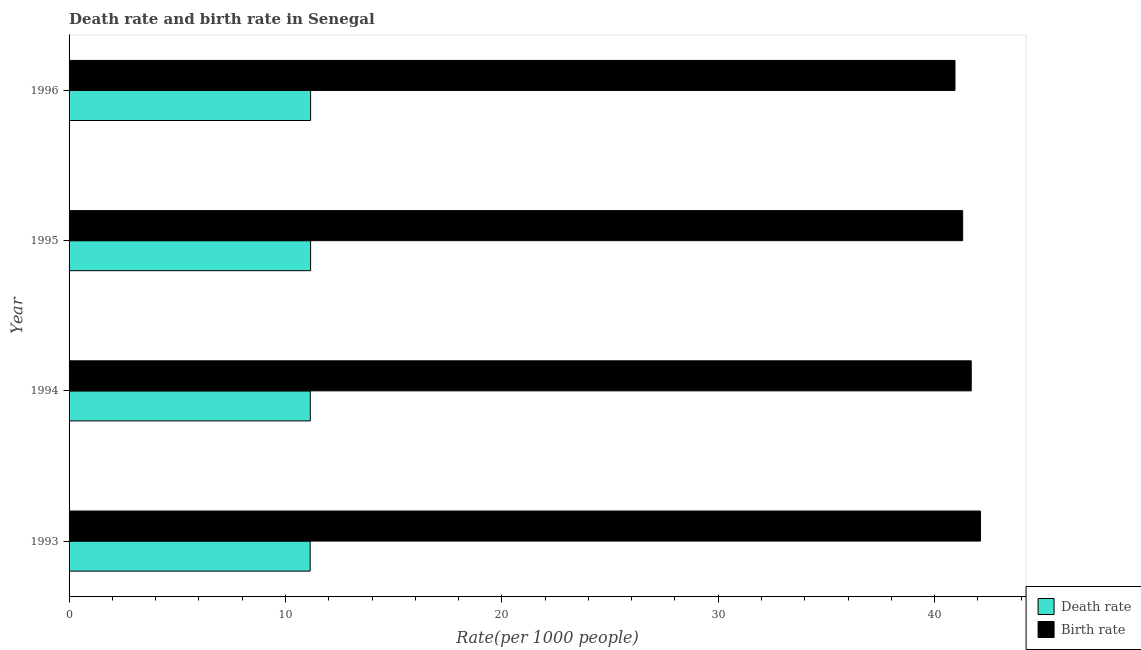How many groups of bars are there?
Offer a terse response. 4. Are the number of bars per tick equal to the number of legend labels?
Provide a short and direct response. Yes. How many bars are there on the 2nd tick from the bottom?
Provide a short and direct response. 2. What is the label of the 1st group of bars from the top?
Your answer should be very brief. 1996. In how many cases, is the number of bars for a given year not equal to the number of legend labels?
Provide a succinct answer. 0. What is the death rate in 1995?
Ensure brevity in your answer.  11.16. Across all years, what is the maximum death rate?
Ensure brevity in your answer.  11.16. Across all years, what is the minimum birth rate?
Keep it short and to the point. 40.94. In which year was the birth rate minimum?
Your answer should be compact. 1996. What is the total death rate in the graph?
Keep it short and to the point. 44.62. What is the difference between the birth rate in 1993 and that in 1994?
Offer a terse response. 0.43. What is the difference between the death rate in 1993 and the birth rate in 1996?
Offer a terse response. -29.8. What is the average birth rate per year?
Ensure brevity in your answer.  41.52. In the year 1996, what is the difference between the birth rate and death rate?
Offer a very short reply. 29.78. Is the difference between the death rate in 1994 and 1995 greater than the difference between the birth rate in 1994 and 1995?
Offer a terse response. No. What is the difference between the highest and the lowest birth rate?
Your response must be concise. 1.18. In how many years, is the death rate greater than the average death rate taken over all years?
Your answer should be very brief. 2. Is the sum of the death rate in 1994 and 1995 greater than the maximum birth rate across all years?
Provide a succinct answer. No. What does the 1st bar from the top in 1993 represents?
Provide a succinct answer. Birth rate. What does the 1st bar from the bottom in 1995 represents?
Make the answer very short. Death rate. How many bars are there?
Provide a short and direct response. 8. Are all the bars in the graph horizontal?
Keep it short and to the point. Yes. How many years are there in the graph?
Provide a short and direct response. 4. What is the difference between two consecutive major ticks on the X-axis?
Keep it short and to the point. 10. Are the values on the major ticks of X-axis written in scientific E-notation?
Your answer should be compact. No. Does the graph contain grids?
Your response must be concise. No. Where does the legend appear in the graph?
Ensure brevity in your answer.  Bottom right. How many legend labels are there?
Your answer should be compact. 2. What is the title of the graph?
Offer a very short reply. Death rate and birth rate in Senegal. Does "Food" appear as one of the legend labels in the graph?
Provide a short and direct response. No. What is the label or title of the X-axis?
Keep it short and to the point. Rate(per 1000 people). What is the label or title of the Y-axis?
Your response must be concise. Year. What is the Rate(per 1000 people) in Death rate in 1993?
Your answer should be compact. 11.14. What is the Rate(per 1000 people) of Birth rate in 1993?
Give a very brief answer. 42.12. What is the Rate(per 1000 people) in Death rate in 1994?
Offer a very short reply. 11.15. What is the Rate(per 1000 people) in Birth rate in 1994?
Your answer should be compact. 41.7. What is the Rate(per 1000 people) of Death rate in 1995?
Provide a succinct answer. 11.16. What is the Rate(per 1000 people) in Birth rate in 1995?
Provide a short and direct response. 41.3. What is the Rate(per 1000 people) of Death rate in 1996?
Offer a very short reply. 11.16. What is the Rate(per 1000 people) in Birth rate in 1996?
Ensure brevity in your answer.  40.94. Across all years, what is the maximum Rate(per 1000 people) of Death rate?
Ensure brevity in your answer.  11.16. Across all years, what is the maximum Rate(per 1000 people) in Birth rate?
Keep it short and to the point. 42.12. Across all years, what is the minimum Rate(per 1000 people) in Death rate?
Ensure brevity in your answer.  11.14. Across all years, what is the minimum Rate(per 1000 people) of Birth rate?
Make the answer very short. 40.94. What is the total Rate(per 1000 people) of Death rate in the graph?
Ensure brevity in your answer.  44.62. What is the total Rate(per 1000 people) in Birth rate in the graph?
Your answer should be very brief. 166.06. What is the difference between the Rate(per 1000 people) in Death rate in 1993 and that in 1994?
Provide a short and direct response. -0.01. What is the difference between the Rate(per 1000 people) of Birth rate in 1993 and that in 1994?
Provide a succinct answer. 0.43. What is the difference between the Rate(per 1000 people) in Death rate in 1993 and that in 1995?
Provide a short and direct response. -0.02. What is the difference between the Rate(per 1000 people) in Birth rate in 1993 and that in 1995?
Keep it short and to the point. 0.82. What is the difference between the Rate(per 1000 people) of Death rate in 1993 and that in 1996?
Ensure brevity in your answer.  -0.02. What is the difference between the Rate(per 1000 people) of Birth rate in 1993 and that in 1996?
Offer a terse response. 1.18. What is the difference between the Rate(per 1000 people) in Death rate in 1994 and that in 1995?
Your answer should be compact. -0.01. What is the difference between the Rate(per 1000 people) in Birth rate in 1994 and that in 1995?
Your response must be concise. 0.4. What is the difference between the Rate(per 1000 people) of Death rate in 1994 and that in 1996?
Give a very brief answer. -0.01. What is the difference between the Rate(per 1000 people) in Birth rate in 1994 and that in 1996?
Offer a terse response. 0.75. What is the difference between the Rate(per 1000 people) of Death rate in 1995 and that in 1996?
Your response must be concise. -0. What is the difference between the Rate(per 1000 people) of Birth rate in 1995 and that in 1996?
Your answer should be compact. 0.35. What is the difference between the Rate(per 1000 people) in Death rate in 1993 and the Rate(per 1000 people) in Birth rate in 1994?
Ensure brevity in your answer.  -30.55. What is the difference between the Rate(per 1000 people) of Death rate in 1993 and the Rate(per 1000 people) of Birth rate in 1995?
Provide a short and direct response. -30.16. What is the difference between the Rate(per 1000 people) in Death rate in 1993 and the Rate(per 1000 people) in Birth rate in 1996?
Keep it short and to the point. -29.8. What is the difference between the Rate(per 1000 people) of Death rate in 1994 and the Rate(per 1000 people) of Birth rate in 1995?
Give a very brief answer. -30.15. What is the difference between the Rate(per 1000 people) of Death rate in 1994 and the Rate(per 1000 people) of Birth rate in 1996?
Ensure brevity in your answer.  -29.8. What is the difference between the Rate(per 1000 people) in Death rate in 1995 and the Rate(per 1000 people) in Birth rate in 1996?
Offer a very short reply. -29.78. What is the average Rate(per 1000 people) in Death rate per year?
Provide a succinct answer. 11.15. What is the average Rate(per 1000 people) of Birth rate per year?
Offer a terse response. 41.52. In the year 1993, what is the difference between the Rate(per 1000 people) in Death rate and Rate(per 1000 people) in Birth rate?
Your response must be concise. -30.98. In the year 1994, what is the difference between the Rate(per 1000 people) of Death rate and Rate(per 1000 people) of Birth rate?
Your answer should be very brief. -30.55. In the year 1995, what is the difference between the Rate(per 1000 people) of Death rate and Rate(per 1000 people) of Birth rate?
Your answer should be compact. -30.14. In the year 1996, what is the difference between the Rate(per 1000 people) of Death rate and Rate(per 1000 people) of Birth rate?
Your answer should be compact. -29.78. What is the ratio of the Rate(per 1000 people) in Death rate in 1993 to that in 1994?
Provide a short and direct response. 1. What is the ratio of the Rate(per 1000 people) in Birth rate in 1993 to that in 1994?
Provide a short and direct response. 1.01. What is the ratio of the Rate(per 1000 people) of Death rate in 1993 to that in 1996?
Keep it short and to the point. 1. What is the ratio of the Rate(per 1000 people) of Birth rate in 1993 to that in 1996?
Give a very brief answer. 1.03. What is the ratio of the Rate(per 1000 people) of Birth rate in 1994 to that in 1995?
Provide a succinct answer. 1.01. What is the ratio of the Rate(per 1000 people) of Death rate in 1994 to that in 1996?
Your response must be concise. 1. What is the ratio of the Rate(per 1000 people) of Birth rate in 1994 to that in 1996?
Provide a short and direct response. 1.02. What is the ratio of the Rate(per 1000 people) in Birth rate in 1995 to that in 1996?
Offer a terse response. 1.01. What is the difference between the highest and the second highest Rate(per 1000 people) in Death rate?
Offer a very short reply. 0. What is the difference between the highest and the second highest Rate(per 1000 people) in Birth rate?
Give a very brief answer. 0.43. What is the difference between the highest and the lowest Rate(per 1000 people) in Death rate?
Your answer should be very brief. 0.02. What is the difference between the highest and the lowest Rate(per 1000 people) in Birth rate?
Offer a terse response. 1.18. 